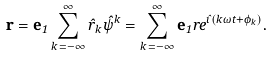<formula> <loc_0><loc_0><loc_500><loc_500>\mathbf r = \mathbf e _ { 1 } \sum _ { k \, = - \infty } ^ { \infty } \hat { r } _ { k } \hat { \psi } ^ { k } = \sum _ { k \, = - \infty } ^ { \infty } \mathbf e _ { 1 } r e ^ { \hat { \imath } ( k \omega t + \phi _ { k } ) } .</formula> 